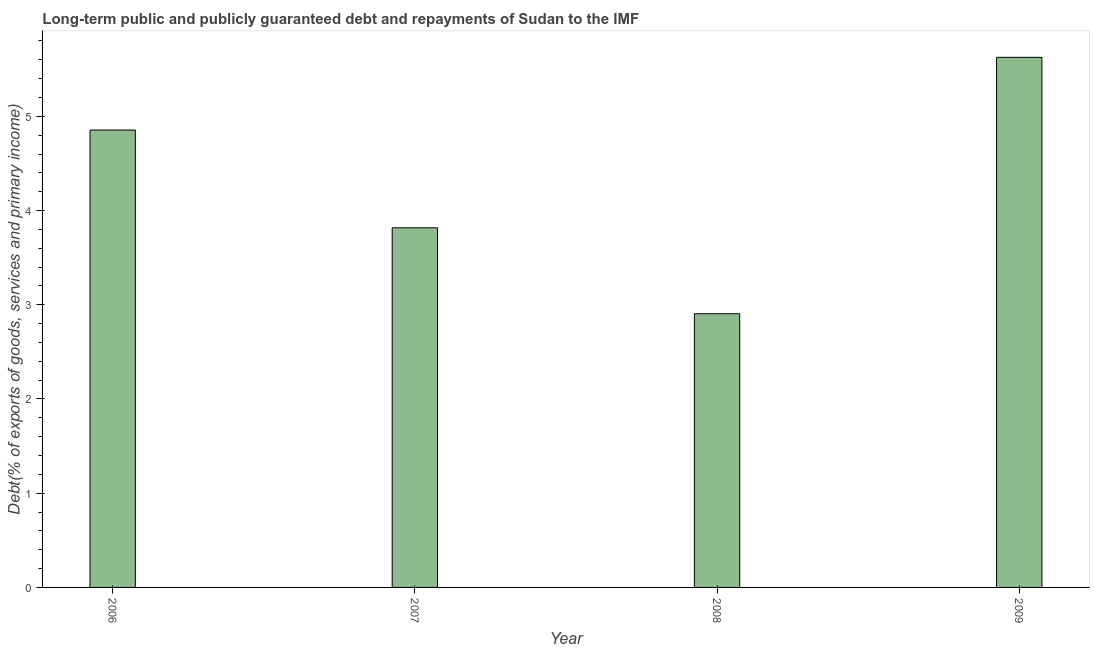Does the graph contain grids?
Ensure brevity in your answer.  No. What is the title of the graph?
Provide a succinct answer. Long-term public and publicly guaranteed debt and repayments of Sudan to the IMF. What is the label or title of the X-axis?
Offer a very short reply. Year. What is the label or title of the Y-axis?
Offer a terse response. Debt(% of exports of goods, services and primary income). What is the debt service in 2008?
Give a very brief answer. 2.91. Across all years, what is the maximum debt service?
Provide a short and direct response. 5.63. Across all years, what is the minimum debt service?
Keep it short and to the point. 2.91. In which year was the debt service maximum?
Give a very brief answer. 2009. In which year was the debt service minimum?
Offer a very short reply. 2008. What is the sum of the debt service?
Provide a succinct answer. 17.2. What is the difference between the debt service in 2006 and 2008?
Your response must be concise. 1.95. What is the average debt service per year?
Offer a terse response. 4.3. What is the median debt service?
Your answer should be very brief. 4.34. Do a majority of the years between 2008 and 2006 (inclusive) have debt service greater than 4.2 %?
Offer a terse response. Yes. What is the ratio of the debt service in 2006 to that in 2007?
Your answer should be very brief. 1.27. Is the difference between the debt service in 2007 and 2009 greater than the difference between any two years?
Provide a succinct answer. No. What is the difference between the highest and the second highest debt service?
Make the answer very short. 0.77. Is the sum of the debt service in 2006 and 2009 greater than the maximum debt service across all years?
Offer a terse response. Yes. What is the difference between the highest and the lowest debt service?
Provide a succinct answer. 2.72. In how many years, is the debt service greater than the average debt service taken over all years?
Your response must be concise. 2. How many bars are there?
Keep it short and to the point. 4. How many years are there in the graph?
Your answer should be compact. 4. What is the difference between two consecutive major ticks on the Y-axis?
Make the answer very short. 1. Are the values on the major ticks of Y-axis written in scientific E-notation?
Give a very brief answer. No. What is the Debt(% of exports of goods, services and primary income) in 2006?
Provide a succinct answer. 4.85. What is the Debt(% of exports of goods, services and primary income) of 2007?
Keep it short and to the point. 3.82. What is the Debt(% of exports of goods, services and primary income) of 2008?
Keep it short and to the point. 2.91. What is the Debt(% of exports of goods, services and primary income) in 2009?
Ensure brevity in your answer.  5.63. What is the difference between the Debt(% of exports of goods, services and primary income) in 2006 and 2007?
Your answer should be compact. 1.04. What is the difference between the Debt(% of exports of goods, services and primary income) in 2006 and 2008?
Keep it short and to the point. 1.95. What is the difference between the Debt(% of exports of goods, services and primary income) in 2006 and 2009?
Keep it short and to the point. -0.77. What is the difference between the Debt(% of exports of goods, services and primary income) in 2007 and 2008?
Give a very brief answer. 0.91. What is the difference between the Debt(% of exports of goods, services and primary income) in 2007 and 2009?
Give a very brief answer. -1.81. What is the difference between the Debt(% of exports of goods, services and primary income) in 2008 and 2009?
Your answer should be compact. -2.72. What is the ratio of the Debt(% of exports of goods, services and primary income) in 2006 to that in 2007?
Make the answer very short. 1.27. What is the ratio of the Debt(% of exports of goods, services and primary income) in 2006 to that in 2008?
Your response must be concise. 1.67. What is the ratio of the Debt(% of exports of goods, services and primary income) in 2006 to that in 2009?
Give a very brief answer. 0.86. What is the ratio of the Debt(% of exports of goods, services and primary income) in 2007 to that in 2008?
Give a very brief answer. 1.31. What is the ratio of the Debt(% of exports of goods, services and primary income) in 2007 to that in 2009?
Your answer should be compact. 0.68. What is the ratio of the Debt(% of exports of goods, services and primary income) in 2008 to that in 2009?
Give a very brief answer. 0.52. 